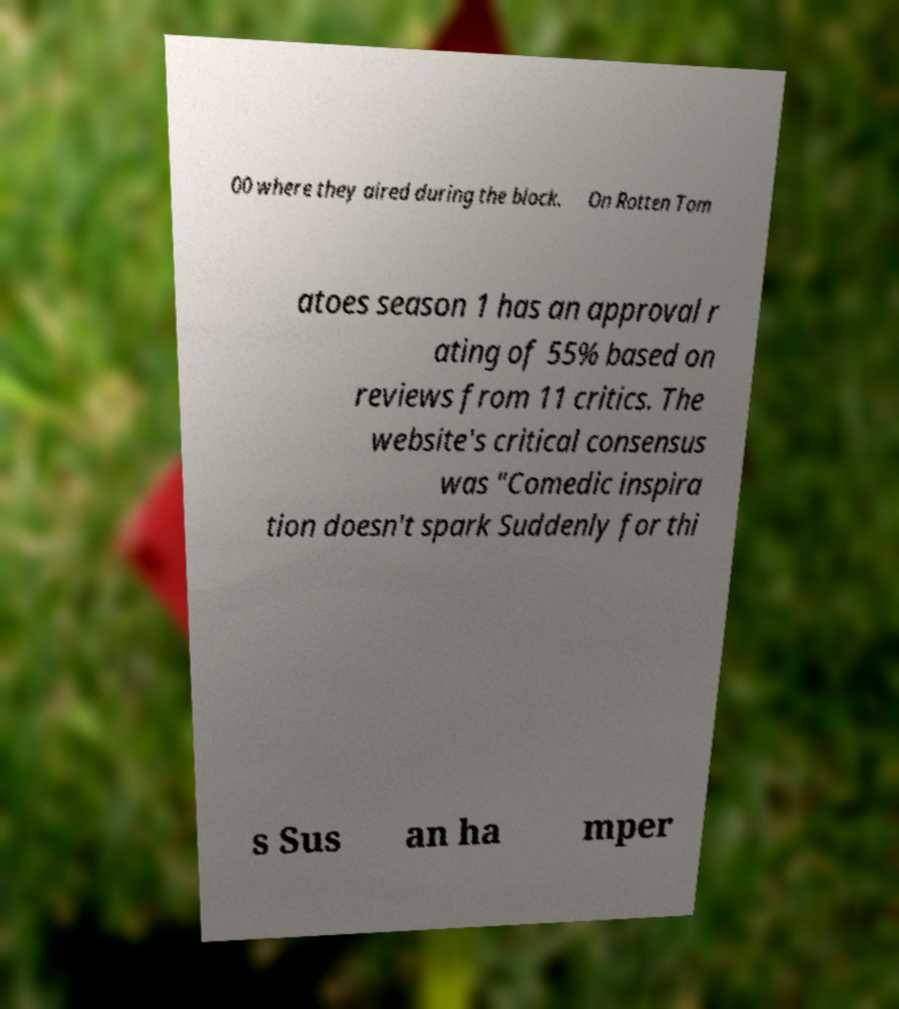Can you read and provide the text displayed in the image?This photo seems to have some interesting text. Can you extract and type it out for me? 00 where they aired during the block. On Rotten Tom atoes season 1 has an approval r ating of 55% based on reviews from 11 critics. The website's critical consensus was "Comedic inspira tion doesn't spark Suddenly for thi s Sus an ha mper 